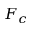<formula> <loc_0><loc_0><loc_500><loc_500>F _ { c }</formula> 